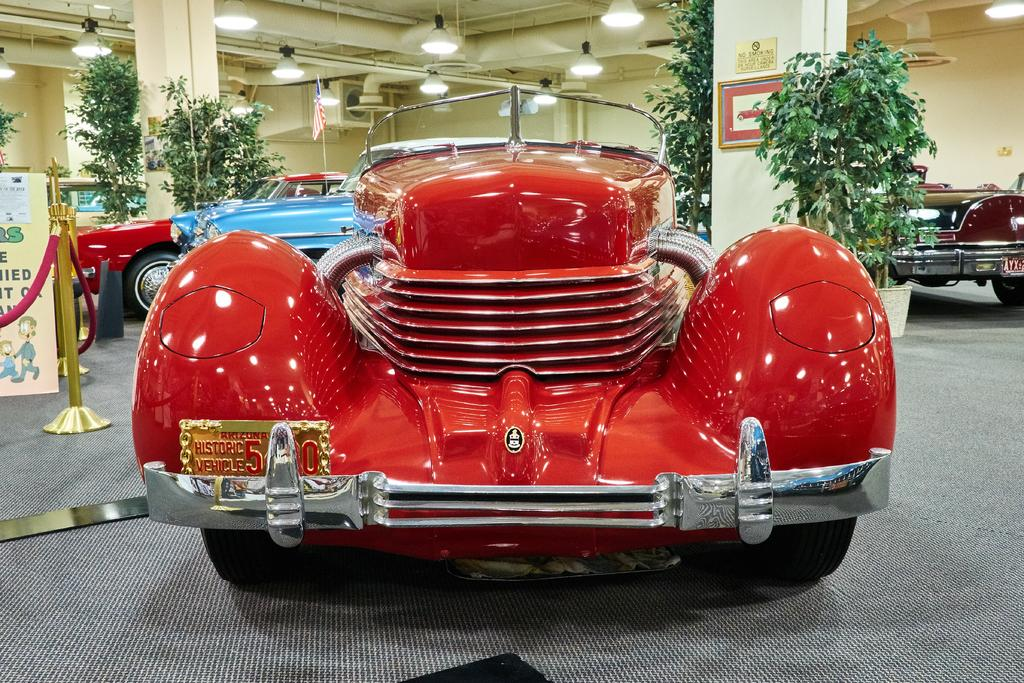What color is present in the middle of the image? There is a red color in the middle of the image. What can be seen in the background of the image? There are other cars and plants in the background of the image. What type of structure is visible in the background? There is a wall in the background of the image. What is present at the top of the image? There are lights at the top of the image. Can you tell me how many roses are on the doctor's desk in the image? There is no doctor or desk present in the image, and therefore no roses can be observed. 